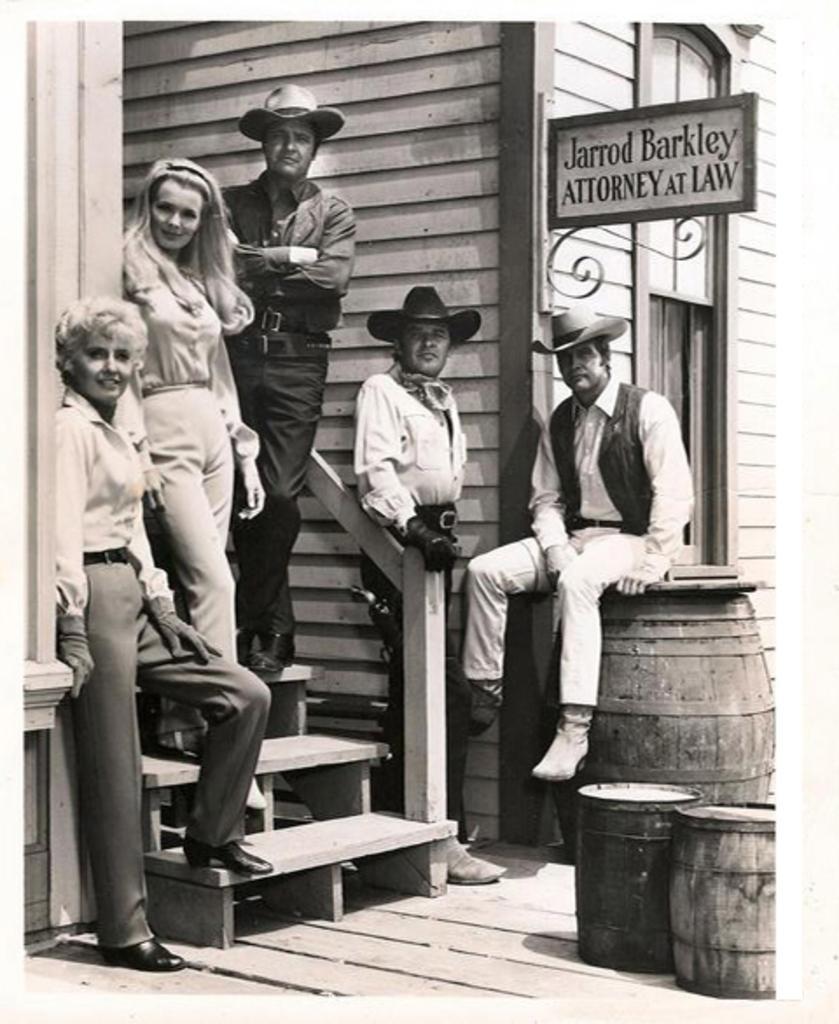In one or two sentences, can you explain what this image depicts? It is a black and white image, on the left side 2 men are standing, they wore t-shirts, trousers. In the middle a man is standing on the staircase, he wore that, shirt, trouser. On the right side a man is sitting on the barrel and also there is a board to this wooden house. 